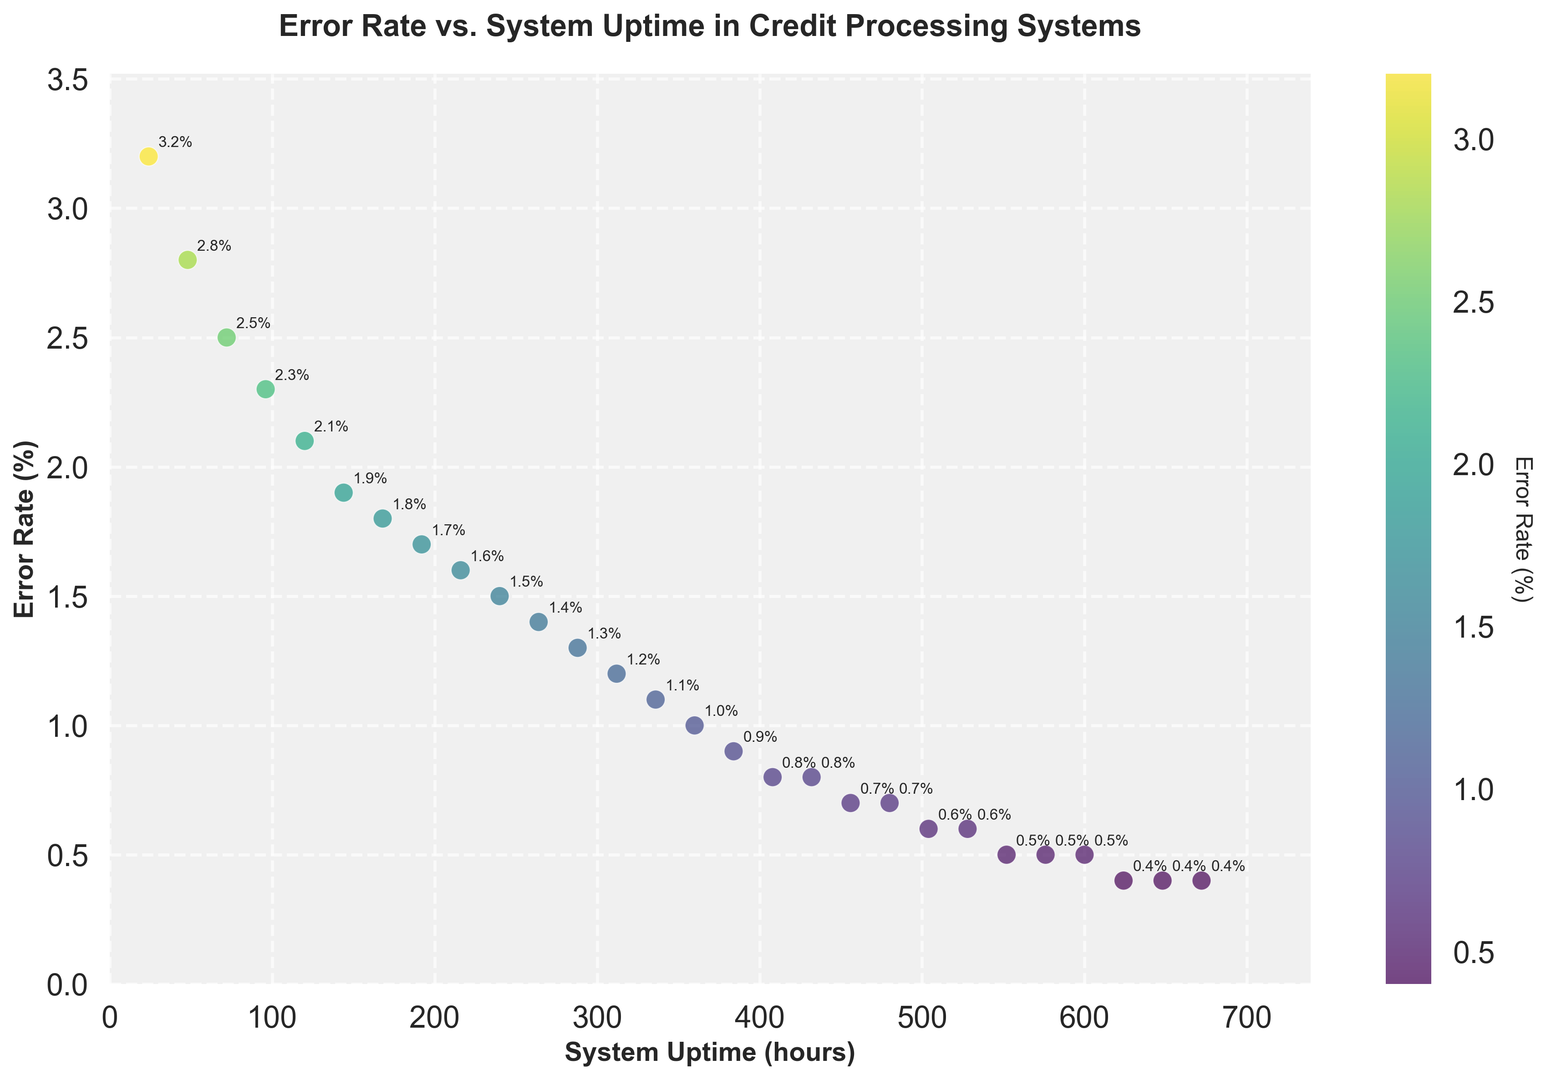What's the trend between system uptime and error rate? As we observe the scatter plot, there’s a clear downward trend where error rates decrease as system uptime increases. This suggests that error rates improve (decrease) with higher system uptime.
Answer: Error rates decrease with higher system uptime What is the error rate when the system uptime is 240 hours? By looking at the scatter plot and identifying the point corresponding to 240 hours on the x-axis, we can see that the error rate is marked as 1.5%.
Answer: 1.5% Which data point has the highest error rate, and what is its system uptime? The data point with the highest error rate is represented by the highest-placed dot on the y-axis. This point shows an error rate of 3.2%, which corresponds to a system uptime of 24 hours.
Answer: 3.2%, 24 hours By how much does the error rate decrease from 24 hours to 48 hours of system uptime? The error rate at 24 hours is 3.2%, and at 48 hours it is 2.8%. The decrease is calculated by subtracting the two values: 3.2% - 2.8% = 0.4%.
Answer: 0.4% What is the lowest recorded error rate in the data set, and at what uptime does it occur? The scatter plot shows that the lowest error rate recorded is 0.4%, and it occurs at multiple uptimes, namely 624, 648, and 672 hours.
Answer: 0.4%, 624, 648, and 672 hours How does the error rate change between 336 hours and 384 hours of system uptime? At 336 hours, the error rate is 1.1%, and at 384 hours, it is 0.9%. The change is calculated by subtracting: 1.1% - 0.9% = 0.2%.
Answer: Decreases by 0.2% Compare the error rates at 504 hours and 552 hours of system uptime. Are they the same or different? From the scatter plot, the points at both 504 hours and 552 hours show an error rate of 0.6%. Hence, the error rates are the same.
Answer: The same By how much does the error rate decrease from 120 hours to 600 hours of system uptime? The error rates at 120 hours and 600 hours are 2.1% and 0.5%, respectively. The decrease is calculated as 2.1% - 0.5% = 1.6%.
Answer: 1.6% Calculate the approximate average error rate for the data points shown. Adding up all the error rates (3.2 + 2.8 + 2.5 + 2.3 + 2.1 + 1.9 + 1.8 + 1.7 + 1.6 + 1.5 + 1.4 + 1.3 + 1.2 + 1.1 + 1 + 0.9 + 0.8 + 0.8 + 0.7 + 0.7 + 0.6 + 0.6 + 0.5 + 0.5 + 0.5 + 0.4 + 0.4 + 0.4) gives 38.1%. Dividing this sum by the number of data points (28) gives the average error rate: 38.1 / 28 ≈ 1.36%.
Answer: 1.36% 